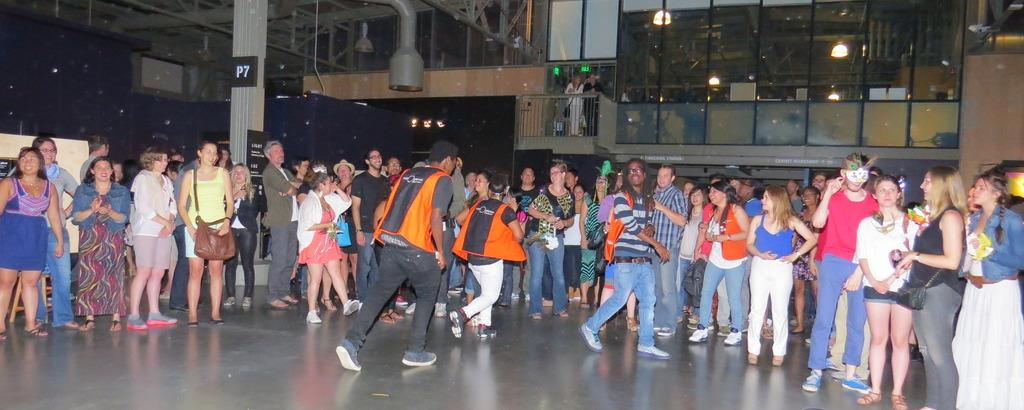How many people are in the image? There is a group of people in the image. What can be observed about the clothing of the people in the image? The people are wearing different color dresses. What type of structure is visible in the image? There is a wall in the image. What material is the wall made of? The wall is made of glass. How many fingers does the daughter of the man in the image have? There is no mention of a daughter or a man in the image, so it is impossible to answer this question. 